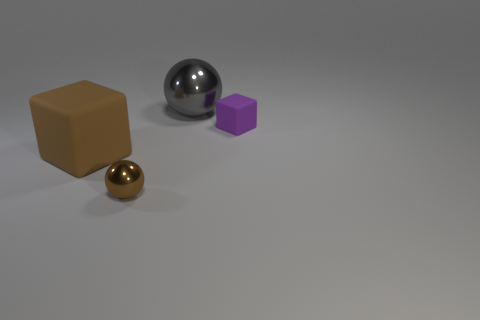Add 2 shiny objects. How many objects exist? 6 Add 4 brown metal things. How many brown metal things are left? 5 Add 1 large brown matte cubes. How many large brown matte cubes exist? 2 Subtract 0 purple cylinders. How many objects are left? 4 Subtract all cyan metal spheres. Subtract all small spheres. How many objects are left? 3 